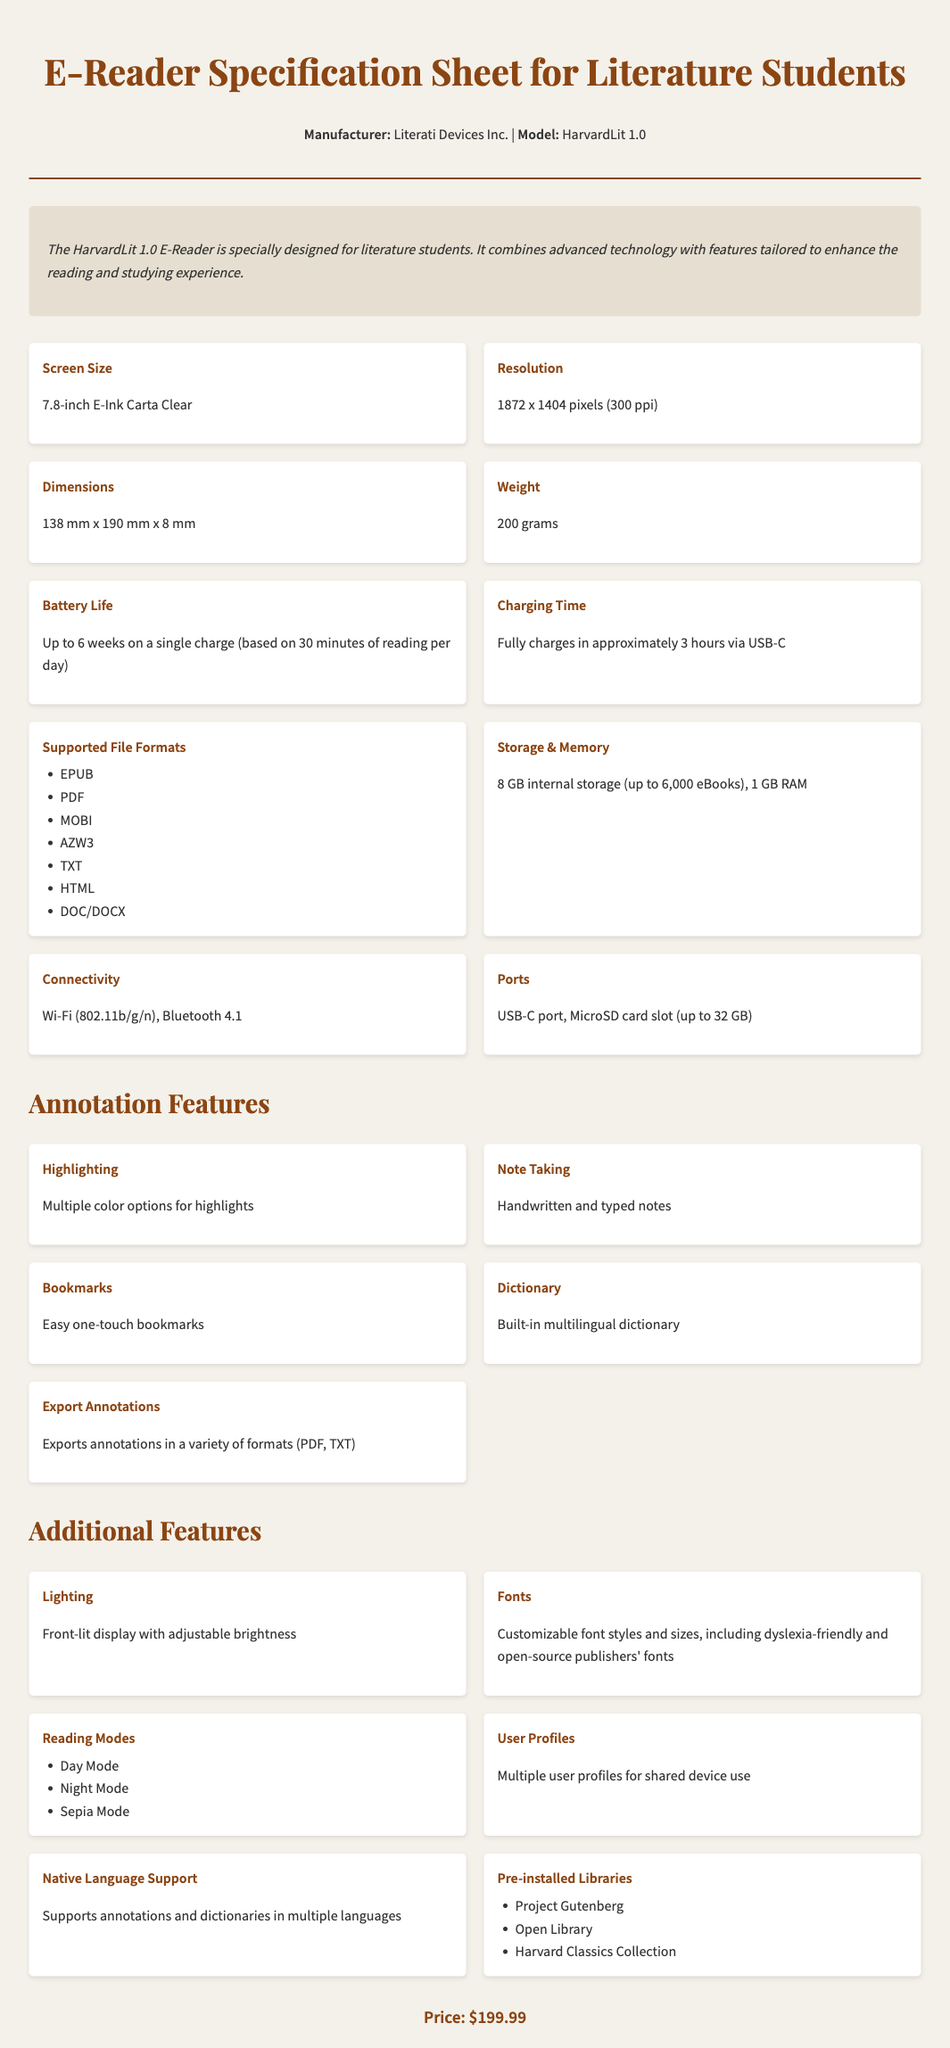What is the model name of the e-reader? The model name is indicated in the header of the document as "HarvardLit 1.0."
Answer: HarvardLit 1.0 What is the screen size of the e-reader? The screen size is specified in the specifications section of the document.
Answer: 7.8-inch What is the battery life? The battery life is detailed in the specifications section, indicating the duration on a single charge.
Answer: Up to 6 weeks How long does it take to fully charge the device? The charging time is explicitly mentioned in the specifications section of the document.
Answer: Approximately 3 hours What file formats are supported by the e-reader? The supported file formats are listed under the specifications section and include several types.
Answer: EPUB, PDF, MOBI, AZW3, TXT, HTML, DOC/DOCX What annotation feature allows handwritten notes? The document lists features, including how notes can be made.
Answer: Note Taking What additional reading mode options does the e-reader have? The reading modes are specified in the additional features section and present different settings.
Answer: Day Mode, Night Mode, Sepia Mode Which pre-installed library specifically relates to Harvard? The document mentions collections included within the e-reader's features.
Answer: Harvard Classics Collection What is the price of the e-reader? The price is clearly stated at the end of the document, summarizing the cost of the product.
Answer: $199.99 